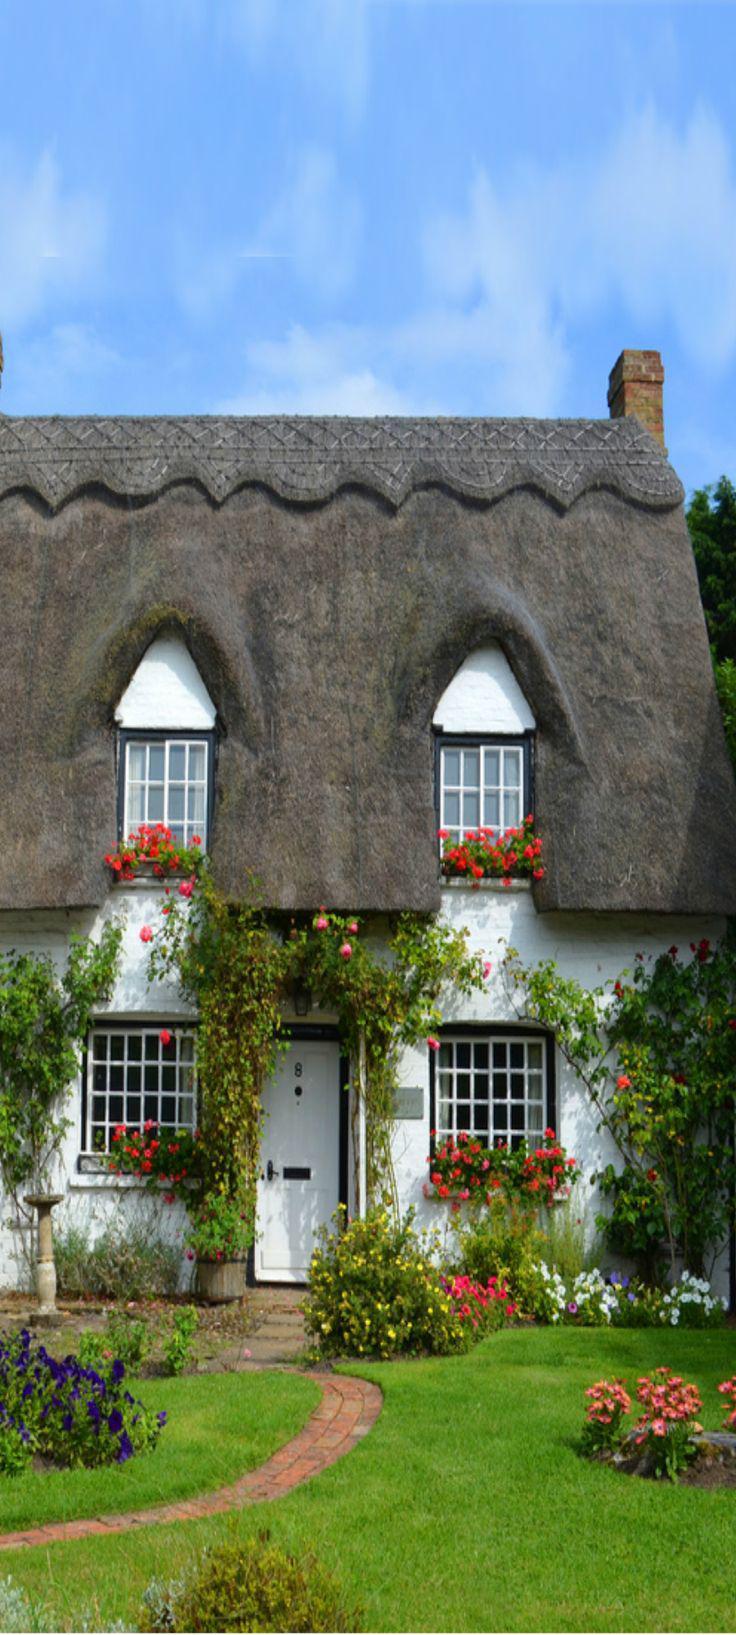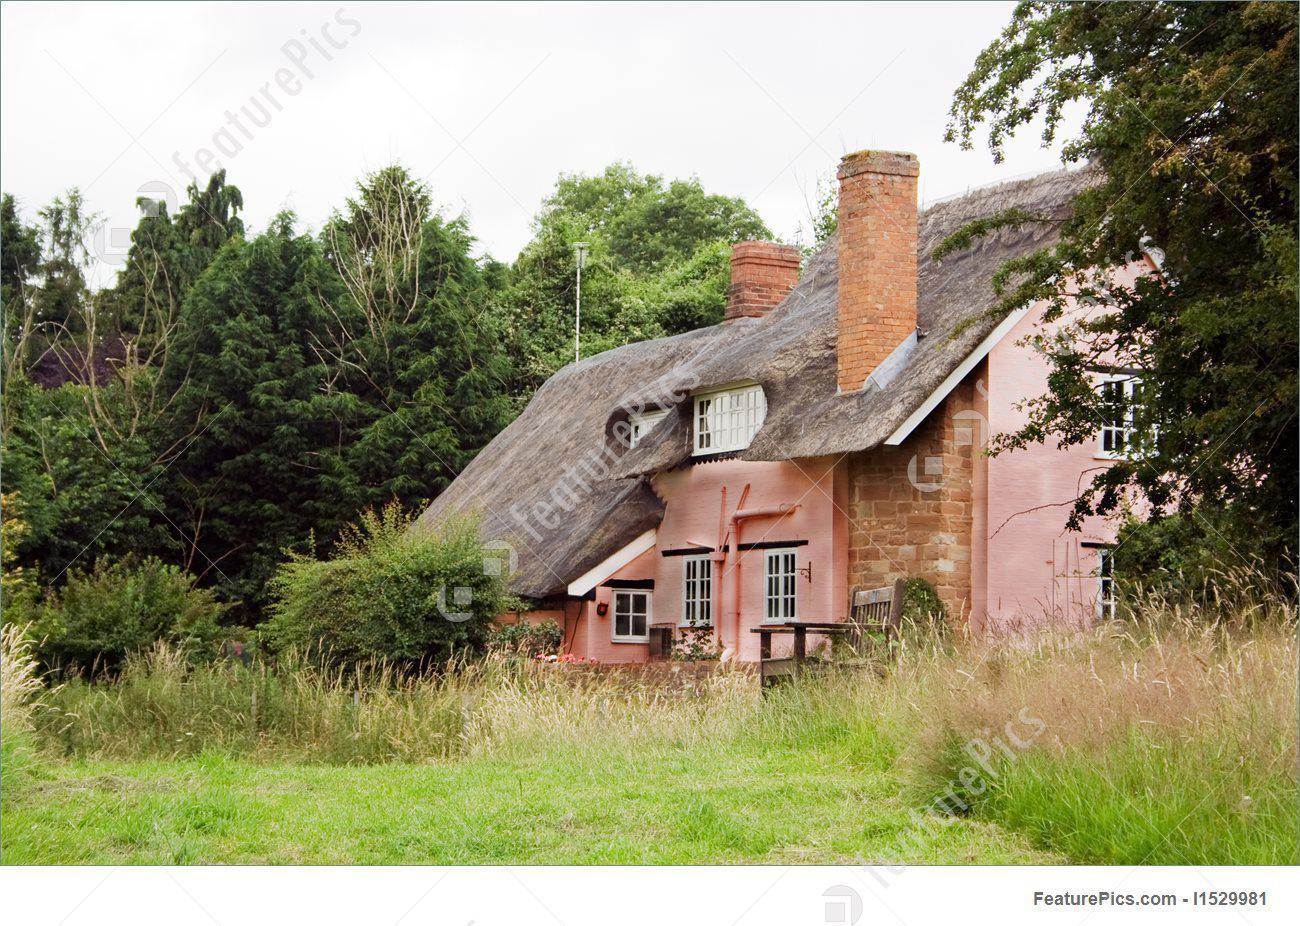The first image is the image on the left, the second image is the image on the right. Evaluate the accuracy of this statement regarding the images: "there is a home with a thatch roof, fencing and flowers are next to the home". Is it true? Answer yes or no. No. 